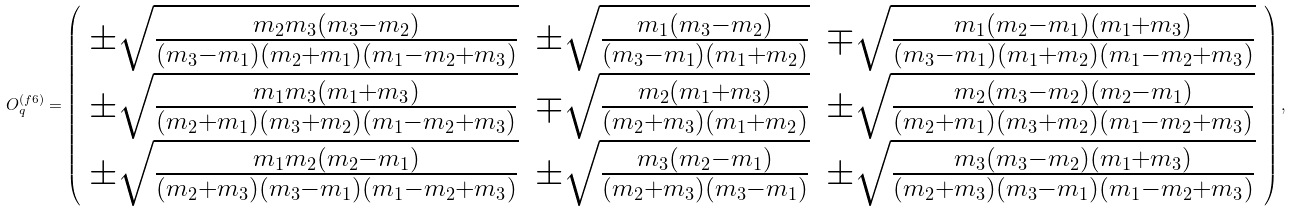<formula> <loc_0><loc_0><loc_500><loc_500>O _ { q } ^ { ( f 6 ) } = \left ( \begin{array} { c c c } \pm \sqrt { \frac { m _ { 2 } m _ { 3 } ( m _ { 3 } - m _ { 2 } ) } { ( m _ { 3 } - m _ { 1 } ) ( m _ { 2 } + m _ { 1 } ) ( m _ { 1 } - m _ { 2 } + m _ { 3 } ) } } & \pm \sqrt { \frac { m _ { 1 } ( m _ { 3 } - m _ { 2 } ) } { ( m _ { 3 } - m _ { 1 } ) ( m _ { 1 } + m _ { 2 } ) } } & \mp \sqrt { \frac { m _ { 1 } ( m _ { 2 } - m _ { 1 } ) ( m _ { 1 } + m _ { 3 } ) } { ( m _ { 3 } - m _ { 1 } ) ( m _ { 1 } + m _ { 2 } ) ( m _ { 1 } - m _ { 2 } + m _ { 3 } ) } } \\ \pm \sqrt { \frac { m _ { 1 } m _ { 3 } ( m _ { 1 } + m _ { 3 } ) } { ( m _ { 2 } + m _ { 1 } ) ( m _ { 3 } + m _ { 2 } ) ( m _ { 1 } - m _ { 2 } + m _ { 3 } ) } } & \mp \sqrt { \frac { m _ { 2 } ( m _ { 1 } + m _ { 3 } ) } { ( m _ { 2 } + m _ { 3 } ) ( m _ { 1 } + m _ { 2 } ) } } & \pm \sqrt { \frac { m _ { 2 } ( m _ { 3 } - m _ { 2 } ) ( m _ { 2 } - m _ { 1 } ) } { ( m _ { 2 } + m _ { 1 } ) ( m _ { 3 } + m _ { 2 } ) ( m _ { 1 } - m _ { 2 } + m _ { 3 } ) } } \\ \pm \sqrt { \frac { m _ { 1 } m _ { 2 } ( m _ { 2 } - m _ { 1 } ) } { ( m _ { 2 } + m _ { 3 } ) ( m _ { 3 } - m _ { 1 } ) ( m _ { 1 } - m _ { 2 } + m _ { 3 } ) } } & \pm \sqrt { \frac { m _ { 3 } ( m _ { 2 } - m _ { 1 } ) } { ( m _ { 2 } + m _ { 3 } ) ( m _ { 3 } - m _ { 1 } ) } } & \pm \sqrt { \frac { m _ { 3 } ( m _ { 3 } - m _ { 2 } ) ( m _ { 1 } + m _ { 3 } ) } { ( m _ { 2 } + m _ { 3 } ) ( m _ { 3 } - m _ { 1 } ) ( m _ { 1 } - m _ { 2 } + m _ { 3 } ) } } \end{array} \right ) ,</formula> 